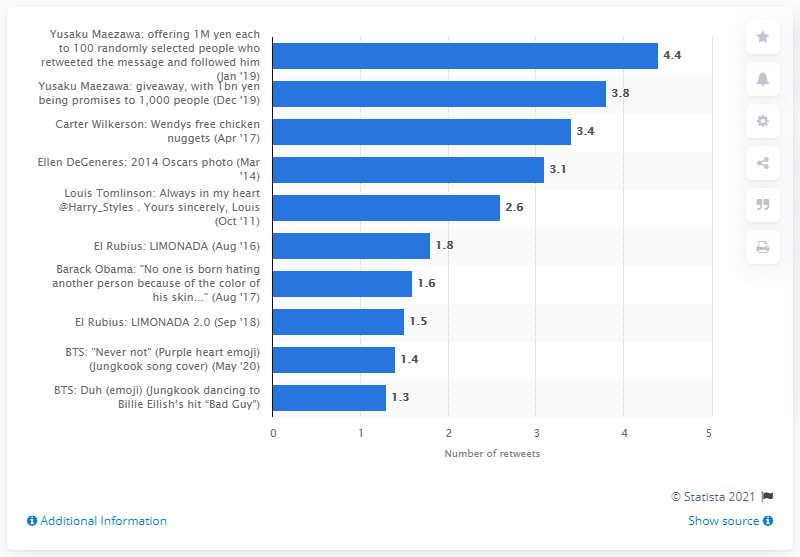Point out several critical features in this image. Ellen DeGeneres' selfie received 3,100 retweets. 